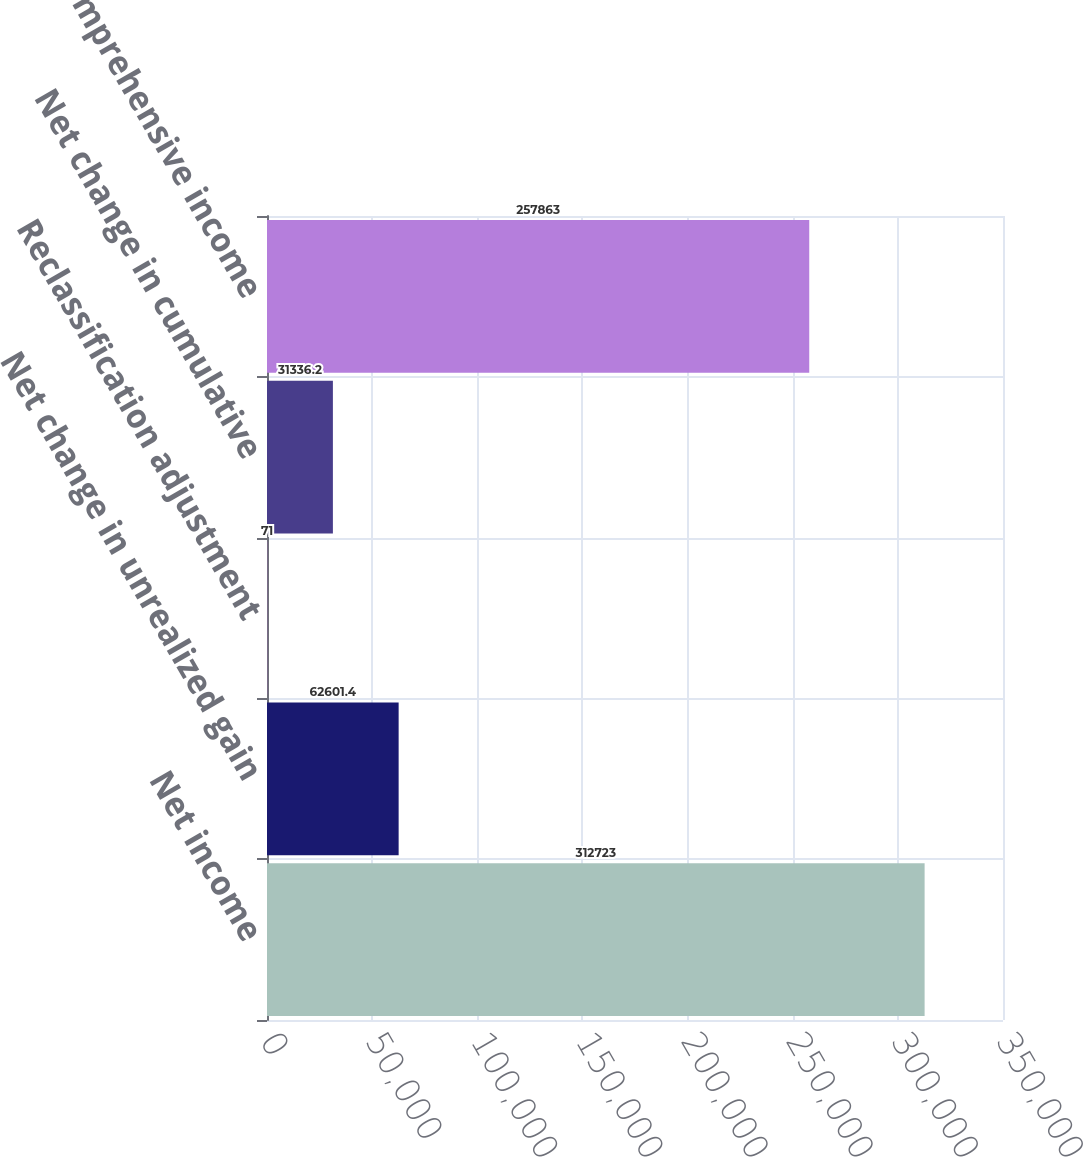<chart> <loc_0><loc_0><loc_500><loc_500><bar_chart><fcel>Net income<fcel>Net change in unrealized gain<fcel>Reclassification adjustment<fcel>Net change in cumulative<fcel>Comprehensive income<nl><fcel>312723<fcel>62601.4<fcel>71<fcel>31336.2<fcel>257863<nl></chart> 